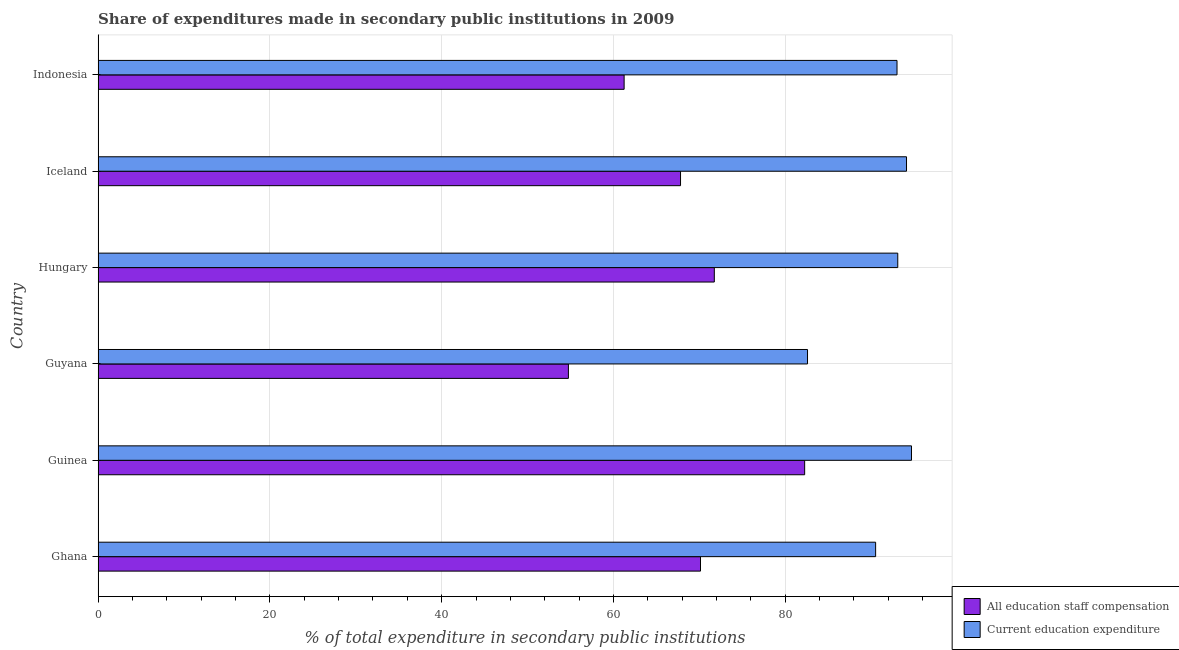How many different coloured bars are there?
Your answer should be very brief. 2. How many groups of bars are there?
Ensure brevity in your answer.  6. Are the number of bars per tick equal to the number of legend labels?
Provide a short and direct response. Yes. How many bars are there on the 3rd tick from the top?
Ensure brevity in your answer.  2. How many bars are there on the 6th tick from the bottom?
Offer a terse response. 2. What is the label of the 5th group of bars from the top?
Make the answer very short. Guinea. What is the expenditure in education in Hungary?
Provide a short and direct response. 93.1. Across all countries, what is the maximum expenditure in education?
Offer a very short reply. 94.69. Across all countries, what is the minimum expenditure in staff compensation?
Your answer should be compact. 54.75. In which country was the expenditure in staff compensation maximum?
Your response must be concise. Guinea. In which country was the expenditure in staff compensation minimum?
Keep it short and to the point. Guyana. What is the total expenditure in staff compensation in the graph?
Make the answer very short. 407.93. What is the difference between the expenditure in staff compensation in Guinea and that in Hungary?
Your answer should be very brief. 10.52. What is the difference between the expenditure in education in Iceland and the expenditure in staff compensation in Indonesia?
Make the answer very short. 32.88. What is the average expenditure in staff compensation per country?
Your response must be concise. 67.99. What is the difference between the expenditure in education and expenditure in staff compensation in Guyana?
Your answer should be compact. 27.84. Is the expenditure in staff compensation in Guinea less than that in Indonesia?
Your answer should be compact. No. Is the difference between the expenditure in staff compensation in Hungary and Indonesia greater than the difference between the expenditure in education in Hungary and Indonesia?
Keep it short and to the point. Yes. What is the difference between the highest and the second highest expenditure in education?
Provide a succinct answer. 0.58. In how many countries, is the expenditure in education greater than the average expenditure in education taken over all countries?
Make the answer very short. 4. What does the 1st bar from the top in Iceland represents?
Provide a succinct answer. Current education expenditure. What does the 2nd bar from the bottom in Guyana represents?
Make the answer very short. Current education expenditure. How many bars are there?
Provide a short and direct response. 12. Are all the bars in the graph horizontal?
Make the answer very short. Yes. What is the difference between two consecutive major ticks on the X-axis?
Offer a terse response. 20. Are the values on the major ticks of X-axis written in scientific E-notation?
Make the answer very short. No. Does the graph contain any zero values?
Your answer should be very brief. No. Where does the legend appear in the graph?
Ensure brevity in your answer.  Bottom right. How are the legend labels stacked?
Offer a very short reply. Vertical. What is the title of the graph?
Offer a terse response. Share of expenditures made in secondary public institutions in 2009. What is the label or title of the X-axis?
Give a very brief answer. % of total expenditure in secondary public institutions. What is the label or title of the Y-axis?
Your answer should be compact. Country. What is the % of total expenditure in secondary public institutions of All education staff compensation in Ghana?
Provide a succinct answer. 70.13. What is the % of total expenditure in secondary public institutions in Current education expenditure in Ghana?
Offer a terse response. 90.52. What is the % of total expenditure in secondary public institutions of All education staff compensation in Guinea?
Make the answer very short. 82.26. What is the % of total expenditure in secondary public institutions of Current education expenditure in Guinea?
Your response must be concise. 94.69. What is the % of total expenditure in secondary public institutions of All education staff compensation in Guyana?
Give a very brief answer. 54.75. What is the % of total expenditure in secondary public institutions in Current education expenditure in Guyana?
Your answer should be very brief. 82.59. What is the % of total expenditure in secondary public institutions in All education staff compensation in Hungary?
Make the answer very short. 71.74. What is the % of total expenditure in secondary public institutions of Current education expenditure in Hungary?
Offer a terse response. 93.1. What is the % of total expenditure in secondary public institutions in All education staff compensation in Iceland?
Your answer should be compact. 67.81. What is the % of total expenditure in secondary public institutions in Current education expenditure in Iceland?
Ensure brevity in your answer.  94.12. What is the % of total expenditure in secondary public institutions in All education staff compensation in Indonesia?
Give a very brief answer. 61.24. What is the % of total expenditure in secondary public institutions of Current education expenditure in Indonesia?
Offer a terse response. 93.01. Across all countries, what is the maximum % of total expenditure in secondary public institutions of All education staff compensation?
Provide a short and direct response. 82.26. Across all countries, what is the maximum % of total expenditure in secondary public institutions in Current education expenditure?
Offer a terse response. 94.69. Across all countries, what is the minimum % of total expenditure in secondary public institutions of All education staff compensation?
Your answer should be very brief. 54.75. Across all countries, what is the minimum % of total expenditure in secondary public institutions of Current education expenditure?
Offer a very short reply. 82.59. What is the total % of total expenditure in secondary public institutions in All education staff compensation in the graph?
Make the answer very short. 407.93. What is the total % of total expenditure in secondary public institutions of Current education expenditure in the graph?
Provide a succinct answer. 548.03. What is the difference between the % of total expenditure in secondary public institutions in All education staff compensation in Ghana and that in Guinea?
Offer a terse response. -12.13. What is the difference between the % of total expenditure in secondary public institutions of Current education expenditure in Ghana and that in Guinea?
Your response must be concise. -4.18. What is the difference between the % of total expenditure in secondary public institutions in All education staff compensation in Ghana and that in Guyana?
Ensure brevity in your answer.  15.38. What is the difference between the % of total expenditure in secondary public institutions in Current education expenditure in Ghana and that in Guyana?
Your answer should be very brief. 7.93. What is the difference between the % of total expenditure in secondary public institutions in All education staff compensation in Ghana and that in Hungary?
Your response must be concise. -1.61. What is the difference between the % of total expenditure in secondary public institutions of Current education expenditure in Ghana and that in Hungary?
Keep it short and to the point. -2.58. What is the difference between the % of total expenditure in secondary public institutions in All education staff compensation in Ghana and that in Iceland?
Give a very brief answer. 2.32. What is the difference between the % of total expenditure in secondary public institutions of Current education expenditure in Ghana and that in Iceland?
Provide a succinct answer. -3.6. What is the difference between the % of total expenditure in secondary public institutions of All education staff compensation in Ghana and that in Indonesia?
Provide a short and direct response. 8.89. What is the difference between the % of total expenditure in secondary public institutions of Current education expenditure in Ghana and that in Indonesia?
Your response must be concise. -2.49. What is the difference between the % of total expenditure in secondary public institutions in All education staff compensation in Guinea and that in Guyana?
Ensure brevity in your answer.  27.5. What is the difference between the % of total expenditure in secondary public institutions of Current education expenditure in Guinea and that in Guyana?
Offer a very short reply. 12.1. What is the difference between the % of total expenditure in secondary public institutions of All education staff compensation in Guinea and that in Hungary?
Keep it short and to the point. 10.52. What is the difference between the % of total expenditure in secondary public institutions of Current education expenditure in Guinea and that in Hungary?
Provide a short and direct response. 1.6. What is the difference between the % of total expenditure in secondary public institutions of All education staff compensation in Guinea and that in Iceland?
Give a very brief answer. 14.45. What is the difference between the % of total expenditure in secondary public institutions in Current education expenditure in Guinea and that in Iceland?
Your answer should be very brief. 0.58. What is the difference between the % of total expenditure in secondary public institutions of All education staff compensation in Guinea and that in Indonesia?
Make the answer very short. 21.02. What is the difference between the % of total expenditure in secondary public institutions of Current education expenditure in Guinea and that in Indonesia?
Provide a short and direct response. 1.68. What is the difference between the % of total expenditure in secondary public institutions of All education staff compensation in Guyana and that in Hungary?
Your answer should be compact. -16.99. What is the difference between the % of total expenditure in secondary public institutions in Current education expenditure in Guyana and that in Hungary?
Provide a short and direct response. -10.51. What is the difference between the % of total expenditure in secondary public institutions of All education staff compensation in Guyana and that in Iceland?
Your answer should be compact. -13.05. What is the difference between the % of total expenditure in secondary public institutions in Current education expenditure in Guyana and that in Iceland?
Your response must be concise. -11.53. What is the difference between the % of total expenditure in secondary public institutions of All education staff compensation in Guyana and that in Indonesia?
Provide a short and direct response. -6.49. What is the difference between the % of total expenditure in secondary public institutions in Current education expenditure in Guyana and that in Indonesia?
Provide a succinct answer. -10.42. What is the difference between the % of total expenditure in secondary public institutions of All education staff compensation in Hungary and that in Iceland?
Offer a terse response. 3.93. What is the difference between the % of total expenditure in secondary public institutions of Current education expenditure in Hungary and that in Iceland?
Offer a terse response. -1.02. What is the difference between the % of total expenditure in secondary public institutions of All education staff compensation in Hungary and that in Indonesia?
Provide a succinct answer. 10.5. What is the difference between the % of total expenditure in secondary public institutions in Current education expenditure in Hungary and that in Indonesia?
Offer a terse response. 0.09. What is the difference between the % of total expenditure in secondary public institutions of All education staff compensation in Iceland and that in Indonesia?
Offer a terse response. 6.57. What is the difference between the % of total expenditure in secondary public institutions of Current education expenditure in Iceland and that in Indonesia?
Offer a very short reply. 1.11. What is the difference between the % of total expenditure in secondary public institutions in All education staff compensation in Ghana and the % of total expenditure in secondary public institutions in Current education expenditure in Guinea?
Provide a succinct answer. -24.56. What is the difference between the % of total expenditure in secondary public institutions of All education staff compensation in Ghana and the % of total expenditure in secondary public institutions of Current education expenditure in Guyana?
Your answer should be compact. -12.46. What is the difference between the % of total expenditure in secondary public institutions in All education staff compensation in Ghana and the % of total expenditure in secondary public institutions in Current education expenditure in Hungary?
Keep it short and to the point. -22.97. What is the difference between the % of total expenditure in secondary public institutions in All education staff compensation in Ghana and the % of total expenditure in secondary public institutions in Current education expenditure in Iceland?
Your response must be concise. -23.99. What is the difference between the % of total expenditure in secondary public institutions in All education staff compensation in Ghana and the % of total expenditure in secondary public institutions in Current education expenditure in Indonesia?
Your response must be concise. -22.88. What is the difference between the % of total expenditure in secondary public institutions of All education staff compensation in Guinea and the % of total expenditure in secondary public institutions of Current education expenditure in Guyana?
Provide a short and direct response. -0.33. What is the difference between the % of total expenditure in secondary public institutions in All education staff compensation in Guinea and the % of total expenditure in secondary public institutions in Current education expenditure in Hungary?
Your answer should be compact. -10.84. What is the difference between the % of total expenditure in secondary public institutions of All education staff compensation in Guinea and the % of total expenditure in secondary public institutions of Current education expenditure in Iceland?
Keep it short and to the point. -11.86. What is the difference between the % of total expenditure in secondary public institutions of All education staff compensation in Guinea and the % of total expenditure in secondary public institutions of Current education expenditure in Indonesia?
Keep it short and to the point. -10.75. What is the difference between the % of total expenditure in secondary public institutions in All education staff compensation in Guyana and the % of total expenditure in secondary public institutions in Current education expenditure in Hungary?
Make the answer very short. -38.34. What is the difference between the % of total expenditure in secondary public institutions in All education staff compensation in Guyana and the % of total expenditure in secondary public institutions in Current education expenditure in Iceland?
Your answer should be very brief. -39.36. What is the difference between the % of total expenditure in secondary public institutions in All education staff compensation in Guyana and the % of total expenditure in secondary public institutions in Current education expenditure in Indonesia?
Your answer should be compact. -38.26. What is the difference between the % of total expenditure in secondary public institutions in All education staff compensation in Hungary and the % of total expenditure in secondary public institutions in Current education expenditure in Iceland?
Your answer should be compact. -22.38. What is the difference between the % of total expenditure in secondary public institutions of All education staff compensation in Hungary and the % of total expenditure in secondary public institutions of Current education expenditure in Indonesia?
Provide a short and direct response. -21.27. What is the difference between the % of total expenditure in secondary public institutions in All education staff compensation in Iceland and the % of total expenditure in secondary public institutions in Current education expenditure in Indonesia?
Your answer should be compact. -25.2. What is the average % of total expenditure in secondary public institutions of All education staff compensation per country?
Give a very brief answer. 67.99. What is the average % of total expenditure in secondary public institutions of Current education expenditure per country?
Offer a terse response. 91.34. What is the difference between the % of total expenditure in secondary public institutions in All education staff compensation and % of total expenditure in secondary public institutions in Current education expenditure in Ghana?
Provide a succinct answer. -20.39. What is the difference between the % of total expenditure in secondary public institutions in All education staff compensation and % of total expenditure in secondary public institutions in Current education expenditure in Guinea?
Make the answer very short. -12.44. What is the difference between the % of total expenditure in secondary public institutions of All education staff compensation and % of total expenditure in secondary public institutions of Current education expenditure in Guyana?
Make the answer very short. -27.84. What is the difference between the % of total expenditure in secondary public institutions of All education staff compensation and % of total expenditure in secondary public institutions of Current education expenditure in Hungary?
Provide a short and direct response. -21.36. What is the difference between the % of total expenditure in secondary public institutions in All education staff compensation and % of total expenditure in secondary public institutions in Current education expenditure in Iceland?
Offer a very short reply. -26.31. What is the difference between the % of total expenditure in secondary public institutions in All education staff compensation and % of total expenditure in secondary public institutions in Current education expenditure in Indonesia?
Offer a terse response. -31.77. What is the ratio of the % of total expenditure in secondary public institutions of All education staff compensation in Ghana to that in Guinea?
Offer a very short reply. 0.85. What is the ratio of the % of total expenditure in secondary public institutions of Current education expenditure in Ghana to that in Guinea?
Provide a succinct answer. 0.96. What is the ratio of the % of total expenditure in secondary public institutions of All education staff compensation in Ghana to that in Guyana?
Keep it short and to the point. 1.28. What is the ratio of the % of total expenditure in secondary public institutions in Current education expenditure in Ghana to that in Guyana?
Provide a succinct answer. 1.1. What is the ratio of the % of total expenditure in secondary public institutions in All education staff compensation in Ghana to that in Hungary?
Provide a short and direct response. 0.98. What is the ratio of the % of total expenditure in secondary public institutions in Current education expenditure in Ghana to that in Hungary?
Ensure brevity in your answer.  0.97. What is the ratio of the % of total expenditure in secondary public institutions in All education staff compensation in Ghana to that in Iceland?
Make the answer very short. 1.03. What is the ratio of the % of total expenditure in secondary public institutions of Current education expenditure in Ghana to that in Iceland?
Your response must be concise. 0.96. What is the ratio of the % of total expenditure in secondary public institutions in All education staff compensation in Ghana to that in Indonesia?
Offer a very short reply. 1.15. What is the ratio of the % of total expenditure in secondary public institutions in Current education expenditure in Ghana to that in Indonesia?
Ensure brevity in your answer.  0.97. What is the ratio of the % of total expenditure in secondary public institutions in All education staff compensation in Guinea to that in Guyana?
Offer a terse response. 1.5. What is the ratio of the % of total expenditure in secondary public institutions of Current education expenditure in Guinea to that in Guyana?
Provide a succinct answer. 1.15. What is the ratio of the % of total expenditure in secondary public institutions of All education staff compensation in Guinea to that in Hungary?
Ensure brevity in your answer.  1.15. What is the ratio of the % of total expenditure in secondary public institutions in Current education expenditure in Guinea to that in Hungary?
Make the answer very short. 1.02. What is the ratio of the % of total expenditure in secondary public institutions in All education staff compensation in Guinea to that in Iceland?
Your answer should be very brief. 1.21. What is the ratio of the % of total expenditure in secondary public institutions of All education staff compensation in Guinea to that in Indonesia?
Offer a very short reply. 1.34. What is the ratio of the % of total expenditure in secondary public institutions of Current education expenditure in Guinea to that in Indonesia?
Give a very brief answer. 1.02. What is the ratio of the % of total expenditure in secondary public institutions of All education staff compensation in Guyana to that in Hungary?
Offer a terse response. 0.76. What is the ratio of the % of total expenditure in secondary public institutions in Current education expenditure in Guyana to that in Hungary?
Ensure brevity in your answer.  0.89. What is the ratio of the % of total expenditure in secondary public institutions in All education staff compensation in Guyana to that in Iceland?
Keep it short and to the point. 0.81. What is the ratio of the % of total expenditure in secondary public institutions of Current education expenditure in Guyana to that in Iceland?
Ensure brevity in your answer.  0.88. What is the ratio of the % of total expenditure in secondary public institutions of All education staff compensation in Guyana to that in Indonesia?
Offer a very short reply. 0.89. What is the ratio of the % of total expenditure in secondary public institutions in Current education expenditure in Guyana to that in Indonesia?
Your answer should be compact. 0.89. What is the ratio of the % of total expenditure in secondary public institutions in All education staff compensation in Hungary to that in Iceland?
Provide a succinct answer. 1.06. What is the ratio of the % of total expenditure in secondary public institutions in All education staff compensation in Hungary to that in Indonesia?
Offer a terse response. 1.17. What is the ratio of the % of total expenditure in secondary public institutions of All education staff compensation in Iceland to that in Indonesia?
Provide a succinct answer. 1.11. What is the ratio of the % of total expenditure in secondary public institutions in Current education expenditure in Iceland to that in Indonesia?
Offer a very short reply. 1.01. What is the difference between the highest and the second highest % of total expenditure in secondary public institutions of All education staff compensation?
Make the answer very short. 10.52. What is the difference between the highest and the second highest % of total expenditure in secondary public institutions of Current education expenditure?
Provide a succinct answer. 0.58. What is the difference between the highest and the lowest % of total expenditure in secondary public institutions of All education staff compensation?
Provide a short and direct response. 27.5. What is the difference between the highest and the lowest % of total expenditure in secondary public institutions in Current education expenditure?
Give a very brief answer. 12.1. 